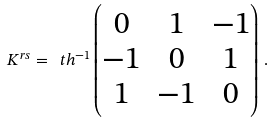Convert formula to latex. <formula><loc_0><loc_0><loc_500><loc_500>K ^ { r s } = \ t h ^ { - 1 } \begin{pmatrix} 0 & 1 & - 1 \\ - 1 & 0 & 1 \\ 1 & - 1 & 0 \end{pmatrix} \, .</formula> 